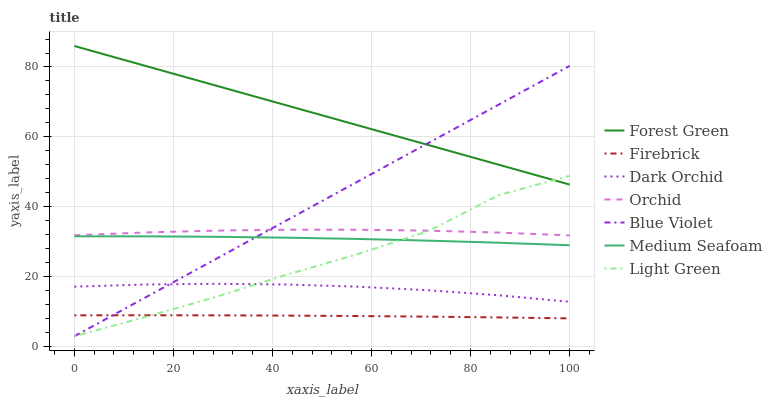Does Firebrick have the minimum area under the curve?
Answer yes or no. Yes. Does Forest Green have the maximum area under the curve?
Answer yes or no. Yes. Does Dark Orchid have the minimum area under the curve?
Answer yes or no. No. Does Dark Orchid have the maximum area under the curve?
Answer yes or no. No. Is Blue Violet the smoothest?
Answer yes or no. Yes. Is Light Green the roughest?
Answer yes or no. Yes. Is Dark Orchid the smoothest?
Answer yes or no. No. Is Dark Orchid the roughest?
Answer yes or no. No. Does Light Green have the lowest value?
Answer yes or no. Yes. Does Dark Orchid have the lowest value?
Answer yes or no. No. Does Forest Green have the highest value?
Answer yes or no. Yes. Does Dark Orchid have the highest value?
Answer yes or no. No. Is Firebrick less than Orchid?
Answer yes or no. Yes. Is Forest Green greater than Orchid?
Answer yes or no. Yes. Does Orchid intersect Blue Violet?
Answer yes or no. Yes. Is Orchid less than Blue Violet?
Answer yes or no. No. Is Orchid greater than Blue Violet?
Answer yes or no. No. Does Firebrick intersect Orchid?
Answer yes or no. No. 